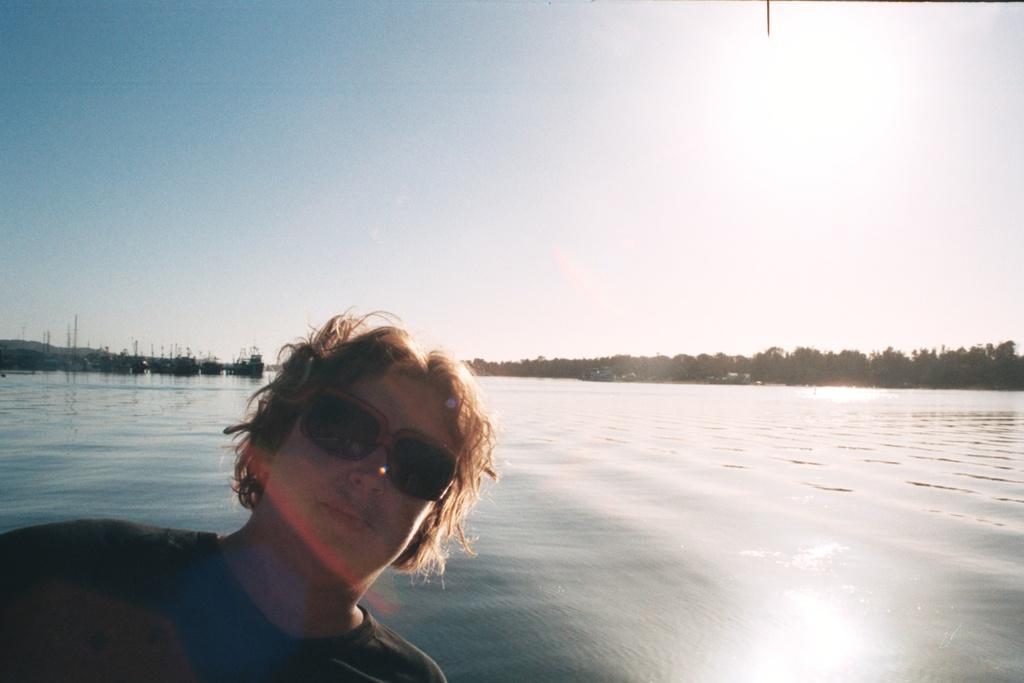How would you summarize this image in a sentence or two? In this picture I can see a person with spectacles, there are boats on the water, there are trees, hills, and in the background there is sky. 